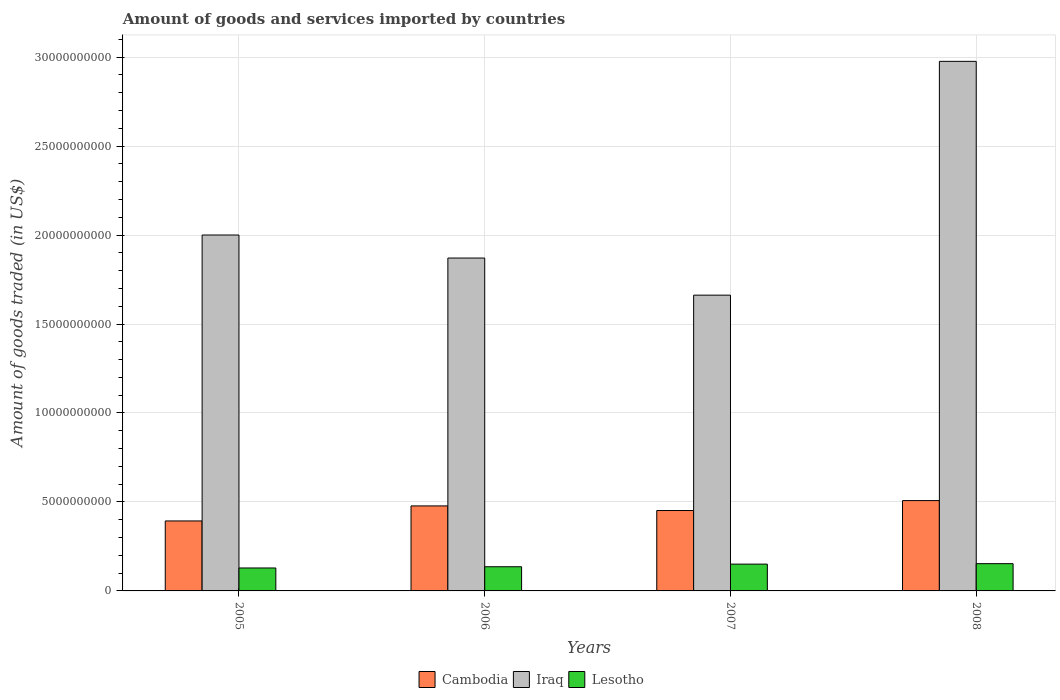Are the number of bars on each tick of the X-axis equal?
Offer a very short reply. Yes. How many bars are there on the 3rd tick from the left?
Ensure brevity in your answer.  3. How many bars are there on the 2nd tick from the right?
Ensure brevity in your answer.  3. What is the label of the 1st group of bars from the left?
Make the answer very short. 2005. What is the total amount of goods and services imported in Cambodia in 2007?
Provide a short and direct response. 4.52e+09. Across all years, what is the maximum total amount of goods and services imported in Lesotho?
Your response must be concise. 1.53e+09. Across all years, what is the minimum total amount of goods and services imported in Iraq?
Your answer should be compact. 1.66e+1. In which year was the total amount of goods and services imported in Lesotho maximum?
Keep it short and to the point. 2008. In which year was the total amount of goods and services imported in Lesotho minimum?
Ensure brevity in your answer.  2005. What is the total total amount of goods and services imported in Cambodia in the graph?
Give a very brief answer. 1.83e+1. What is the difference between the total amount of goods and services imported in Iraq in 2007 and that in 2008?
Offer a terse response. -1.31e+1. What is the difference between the total amount of goods and services imported in Cambodia in 2005 and the total amount of goods and services imported in Iraq in 2006?
Your answer should be very brief. -1.48e+1. What is the average total amount of goods and services imported in Lesotho per year?
Your response must be concise. 1.42e+09. In the year 2007, what is the difference between the total amount of goods and services imported in Cambodia and total amount of goods and services imported in Iraq?
Ensure brevity in your answer.  -1.21e+1. In how many years, is the total amount of goods and services imported in Iraq greater than 23000000000 US$?
Your answer should be very brief. 1. What is the ratio of the total amount of goods and services imported in Iraq in 2005 to that in 2006?
Your response must be concise. 1.07. Is the difference between the total amount of goods and services imported in Cambodia in 2006 and 2007 greater than the difference between the total amount of goods and services imported in Iraq in 2006 and 2007?
Your answer should be compact. No. What is the difference between the highest and the second highest total amount of goods and services imported in Cambodia?
Offer a terse response. 2.99e+08. What is the difference between the highest and the lowest total amount of goods and services imported in Lesotho?
Your response must be concise. 2.42e+08. What does the 1st bar from the left in 2008 represents?
Make the answer very short. Cambodia. What does the 2nd bar from the right in 2005 represents?
Provide a short and direct response. Iraq. Are all the bars in the graph horizontal?
Your answer should be compact. No. How many years are there in the graph?
Your response must be concise. 4. What is the difference between two consecutive major ticks on the Y-axis?
Your answer should be compact. 5.00e+09. Does the graph contain any zero values?
Your answer should be very brief. No. How are the legend labels stacked?
Offer a terse response. Horizontal. What is the title of the graph?
Your answer should be compact. Amount of goods and services imported by countries. Does "Mexico" appear as one of the legend labels in the graph?
Offer a very short reply. No. What is the label or title of the X-axis?
Give a very brief answer. Years. What is the label or title of the Y-axis?
Your response must be concise. Amount of goods traded (in US$). What is the Amount of goods traded (in US$) in Cambodia in 2005?
Ensure brevity in your answer.  3.93e+09. What is the Amount of goods traded (in US$) of Iraq in 2005?
Make the answer very short. 2.00e+1. What is the Amount of goods traded (in US$) in Lesotho in 2005?
Provide a short and direct response. 1.29e+09. What is the Amount of goods traded (in US$) of Cambodia in 2006?
Your answer should be compact. 4.78e+09. What is the Amount of goods traded (in US$) in Iraq in 2006?
Provide a short and direct response. 1.87e+1. What is the Amount of goods traded (in US$) in Lesotho in 2006?
Provide a succinct answer. 1.36e+09. What is the Amount of goods traded (in US$) of Cambodia in 2007?
Ensure brevity in your answer.  4.52e+09. What is the Amount of goods traded (in US$) of Iraq in 2007?
Provide a succinct answer. 1.66e+1. What is the Amount of goods traded (in US$) of Lesotho in 2007?
Give a very brief answer. 1.51e+09. What is the Amount of goods traded (in US$) of Cambodia in 2008?
Give a very brief answer. 5.08e+09. What is the Amount of goods traded (in US$) of Iraq in 2008?
Your answer should be compact. 2.98e+1. What is the Amount of goods traded (in US$) in Lesotho in 2008?
Provide a succinct answer. 1.53e+09. Across all years, what is the maximum Amount of goods traded (in US$) in Cambodia?
Give a very brief answer. 5.08e+09. Across all years, what is the maximum Amount of goods traded (in US$) of Iraq?
Your answer should be very brief. 2.98e+1. Across all years, what is the maximum Amount of goods traded (in US$) of Lesotho?
Offer a terse response. 1.53e+09. Across all years, what is the minimum Amount of goods traded (in US$) in Cambodia?
Provide a succinct answer. 3.93e+09. Across all years, what is the minimum Amount of goods traded (in US$) of Iraq?
Offer a terse response. 1.66e+1. Across all years, what is the minimum Amount of goods traded (in US$) in Lesotho?
Make the answer very short. 1.29e+09. What is the total Amount of goods traded (in US$) of Cambodia in the graph?
Offer a very short reply. 1.83e+1. What is the total Amount of goods traded (in US$) of Iraq in the graph?
Your answer should be compact. 8.51e+1. What is the total Amount of goods traded (in US$) in Lesotho in the graph?
Your response must be concise. 5.69e+09. What is the difference between the Amount of goods traded (in US$) of Cambodia in 2005 and that in 2006?
Your answer should be compact. -8.45e+08. What is the difference between the Amount of goods traded (in US$) in Iraq in 2005 and that in 2006?
Offer a very short reply. 1.29e+09. What is the difference between the Amount of goods traded (in US$) of Lesotho in 2005 and that in 2006?
Make the answer very short. -6.96e+07. What is the difference between the Amount of goods traded (in US$) in Cambodia in 2005 and that in 2007?
Give a very brief answer. -5.86e+08. What is the difference between the Amount of goods traded (in US$) of Iraq in 2005 and that in 2007?
Provide a succinct answer. 3.38e+09. What is the difference between the Amount of goods traded (in US$) of Lesotho in 2005 and that in 2007?
Your answer should be very brief. -2.17e+08. What is the difference between the Amount of goods traded (in US$) of Cambodia in 2005 and that in 2008?
Give a very brief answer. -1.14e+09. What is the difference between the Amount of goods traded (in US$) of Iraq in 2005 and that in 2008?
Offer a terse response. -9.76e+09. What is the difference between the Amount of goods traded (in US$) of Lesotho in 2005 and that in 2008?
Offer a very short reply. -2.42e+08. What is the difference between the Amount of goods traded (in US$) in Cambodia in 2006 and that in 2007?
Offer a terse response. 2.59e+08. What is the difference between the Amount of goods traded (in US$) of Iraq in 2006 and that in 2007?
Give a very brief answer. 2.08e+09. What is the difference between the Amount of goods traded (in US$) of Lesotho in 2006 and that in 2007?
Your answer should be very brief. -1.47e+08. What is the difference between the Amount of goods traded (in US$) of Cambodia in 2006 and that in 2008?
Offer a very short reply. -2.99e+08. What is the difference between the Amount of goods traded (in US$) in Iraq in 2006 and that in 2008?
Offer a very short reply. -1.11e+1. What is the difference between the Amount of goods traded (in US$) of Lesotho in 2006 and that in 2008?
Keep it short and to the point. -1.73e+08. What is the difference between the Amount of goods traded (in US$) of Cambodia in 2007 and that in 2008?
Make the answer very short. -5.58e+08. What is the difference between the Amount of goods traded (in US$) of Iraq in 2007 and that in 2008?
Your answer should be compact. -1.31e+1. What is the difference between the Amount of goods traded (in US$) of Lesotho in 2007 and that in 2008?
Offer a terse response. -2.55e+07. What is the difference between the Amount of goods traded (in US$) of Cambodia in 2005 and the Amount of goods traded (in US$) of Iraq in 2006?
Offer a terse response. -1.48e+1. What is the difference between the Amount of goods traded (in US$) of Cambodia in 2005 and the Amount of goods traded (in US$) of Lesotho in 2006?
Provide a short and direct response. 2.57e+09. What is the difference between the Amount of goods traded (in US$) of Iraq in 2005 and the Amount of goods traded (in US$) of Lesotho in 2006?
Make the answer very short. 1.86e+1. What is the difference between the Amount of goods traded (in US$) in Cambodia in 2005 and the Amount of goods traded (in US$) in Iraq in 2007?
Ensure brevity in your answer.  -1.27e+1. What is the difference between the Amount of goods traded (in US$) in Cambodia in 2005 and the Amount of goods traded (in US$) in Lesotho in 2007?
Give a very brief answer. 2.43e+09. What is the difference between the Amount of goods traded (in US$) of Iraq in 2005 and the Amount of goods traded (in US$) of Lesotho in 2007?
Your answer should be compact. 1.85e+1. What is the difference between the Amount of goods traded (in US$) of Cambodia in 2005 and the Amount of goods traded (in US$) of Iraq in 2008?
Offer a terse response. -2.58e+1. What is the difference between the Amount of goods traded (in US$) of Cambodia in 2005 and the Amount of goods traded (in US$) of Lesotho in 2008?
Provide a short and direct response. 2.40e+09. What is the difference between the Amount of goods traded (in US$) in Iraq in 2005 and the Amount of goods traded (in US$) in Lesotho in 2008?
Your answer should be compact. 1.85e+1. What is the difference between the Amount of goods traded (in US$) in Cambodia in 2006 and the Amount of goods traded (in US$) in Iraq in 2007?
Your answer should be very brief. -1.18e+1. What is the difference between the Amount of goods traded (in US$) in Cambodia in 2006 and the Amount of goods traded (in US$) in Lesotho in 2007?
Provide a short and direct response. 3.27e+09. What is the difference between the Amount of goods traded (in US$) in Iraq in 2006 and the Amount of goods traded (in US$) in Lesotho in 2007?
Offer a very short reply. 1.72e+1. What is the difference between the Amount of goods traded (in US$) of Cambodia in 2006 and the Amount of goods traded (in US$) of Iraq in 2008?
Give a very brief answer. -2.50e+1. What is the difference between the Amount of goods traded (in US$) of Cambodia in 2006 and the Amount of goods traded (in US$) of Lesotho in 2008?
Your answer should be compact. 3.25e+09. What is the difference between the Amount of goods traded (in US$) of Iraq in 2006 and the Amount of goods traded (in US$) of Lesotho in 2008?
Give a very brief answer. 1.72e+1. What is the difference between the Amount of goods traded (in US$) of Cambodia in 2007 and the Amount of goods traded (in US$) of Iraq in 2008?
Provide a succinct answer. -2.52e+1. What is the difference between the Amount of goods traded (in US$) in Cambodia in 2007 and the Amount of goods traded (in US$) in Lesotho in 2008?
Offer a terse response. 2.99e+09. What is the difference between the Amount of goods traded (in US$) in Iraq in 2007 and the Amount of goods traded (in US$) in Lesotho in 2008?
Offer a terse response. 1.51e+1. What is the average Amount of goods traded (in US$) of Cambodia per year?
Your answer should be compact. 4.58e+09. What is the average Amount of goods traded (in US$) of Iraq per year?
Your response must be concise. 2.13e+1. What is the average Amount of goods traded (in US$) of Lesotho per year?
Provide a short and direct response. 1.42e+09. In the year 2005, what is the difference between the Amount of goods traded (in US$) of Cambodia and Amount of goods traded (in US$) of Iraq?
Ensure brevity in your answer.  -1.61e+1. In the year 2005, what is the difference between the Amount of goods traded (in US$) in Cambodia and Amount of goods traded (in US$) in Lesotho?
Your answer should be very brief. 2.64e+09. In the year 2005, what is the difference between the Amount of goods traded (in US$) in Iraq and Amount of goods traded (in US$) in Lesotho?
Your answer should be compact. 1.87e+1. In the year 2006, what is the difference between the Amount of goods traded (in US$) of Cambodia and Amount of goods traded (in US$) of Iraq?
Your answer should be compact. -1.39e+1. In the year 2006, what is the difference between the Amount of goods traded (in US$) of Cambodia and Amount of goods traded (in US$) of Lesotho?
Give a very brief answer. 3.42e+09. In the year 2006, what is the difference between the Amount of goods traded (in US$) in Iraq and Amount of goods traded (in US$) in Lesotho?
Offer a very short reply. 1.73e+1. In the year 2007, what is the difference between the Amount of goods traded (in US$) in Cambodia and Amount of goods traded (in US$) in Iraq?
Your answer should be compact. -1.21e+1. In the year 2007, what is the difference between the Amount of goods traded (in US$) in Cambodia and Amount of goods traded (in US$) in Lesotho?
Offer a terse response. 3.01e+09. In the year 2007, what is the difference between the Amount of goods traded (in US$) in Iraq and Amount of goods traded (in US$) in Lesotho?
Ensure brevity in your answer.  1.51e+1. In the year 2008, what is the difference between the Amount of goods traded (in US$) of Cambodia and Amount of goods traded (in US$) of Iraq?
Your answer should be very brief. -2.47e+1. In the year 2008, what is the difference between the Amount of goods traded (in US$) in Cambodia and Amount of goods traded (in US$) in Lesotho?
Keep it short and to the point. 3.55e+09. In the year 2008, what is the difference between the Amount of goods traded (in US$) in Iraq and Amount of goods traded (in US$) in Lesotho?
Provide a short and direct response. 2.82e+1. What is the ratio of the Amount of goods traded (in US$) of Cambodia in 2005 to that in 2006?
Provide a succinct answer. 0.82. What is the ratio of the Amount of goods traded (in US$) of Iraq in 2005 to that in 2006?
Provide a short and direct response. 1.07. What is the ratio of the Amount of goods traded (in US$) in Lesotho in 2005 to that in 2006?
Offer a terse response. 0.95. What is the ratio of the Amount of goods traded (in US$) of Cambodia in 2005 to that in 2007?
Ensure brevity in your answer.  0.87. What is the ratio of the Amount of goods traded (in US$) of Iraq in 2005 to that in 2007?
Ensure brevity in your answer.  1.2. What is the ratio of the Amount of goods traded (in US$) in Lesotho in 2005 to that in 2007?
Keep it short and to the point. 0.86. What is the ratio of the Amount of goods traded (in US$) in Cambodia in 2005 to that in 2008?
Your response must be concise. 0.77. What is the ratio of the Amount of goods traded (in US$) in Iraq in 2005 to that in 2008?
Offer a very short reply. 0.67. What is the ratio of the Amount of goods traded (in US$) in Lesotho in 2005 to that in 2008?
Ensure brevity in your answer.  0.84. What is the ratio of the Amount of goods traded (in US$) in Cambodia in 2006 to that in 2007?
Provide a succinct answer. 1.06. What is the ratio of the Amount of goods traded (in US$) in Iraq in 2006 to that in 2007?
Your answer should be compact. 1.13. What is the ratio of the Amount of goods traded (in US$) in Lesotho in 2006 to that in 2007?
Your response must be concise. 0.9. What is the ratio of the Amount of goods traded (in US$) of Cambodia in 2006 to that in 2008?
Ensure brevity in your answer.  0.94. What is the ratio of the Amount of goods traded (in US$) in Iraq in 2006 to that in 2008?
Offer a very short reply. 0.63. What is the ratio of the Amount of goods traded (in US$) in Lesotho in 2006 to that in 2008?
Your answer should be compact. 0.89. What is the ratio of the Amount of goods traded (in US$) of Cambodia in 2007 to that in 2008?
Give a very brief answer. 0.89. What is the ratio of the Amount of goods traded (in US$) of Iraq in 2007 to that in 2008?
Offer a very short reply. 0.56. What is the ratio of the Amount of goods traded (in US$) of Lesotho in 2007 to that in 2008?
Give a very brief answer. 0.98. What is the difference between the highest and the second highest Amount of goods traded (in US$) in Cambodia?
Make the answer very short. 2.99e+08. What is the difference between the highest and the second highest Amount of goods traded (in US$) in Iraq?
Offer a very short reply. 9.76e+09. What is the difference between the highest and the second highest Amount of goods traded (in US$) in Lesotho?
Provide a succinct answer. 2.55e+07. What is the difference between the highest and the lowest Amount of goods traded (in US$) in Cambodia?
Give a very brief answer. 1.14e+09. What is the difference between the highest and the lowest Amount of goods traded (in US$) of Iraq?
Provide a succinct answer. 1.31e+1. What is the difference between the highest and the lowest Amount of goods traded (in US$) of Lesotho?
Your answer should be very brief. 2.42e+08. 